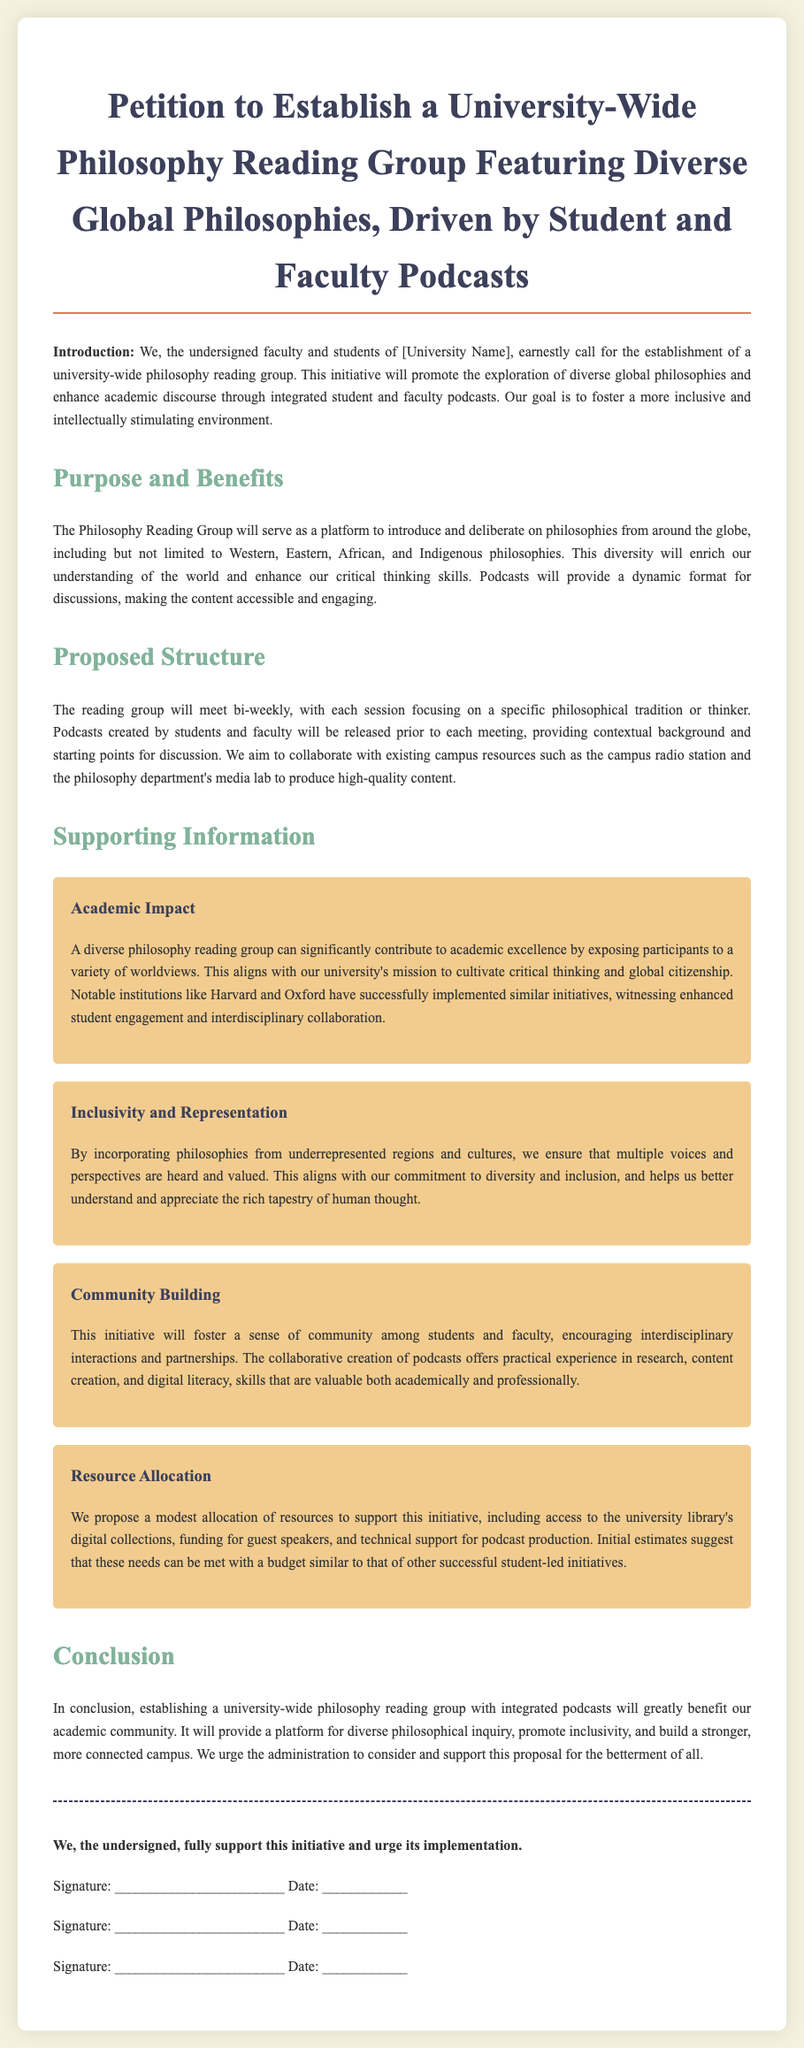What is the title of the petition? The title of the petition is explicitly stated at the beginning of the document.
Answer: Petition to Establish a University-Wide Philosophy Reading Group Featuring Diverse Global Philosophies, Driven by Student and Faculty Podcasts How often will the reading group meet? The document specifies the frequency of the reading group meetings within the proposed structure.
Answer: bi-weekly What will provide context for each discussion session? The document mentions what will be released prior to each meeting to aid discussions.
Answer: Podcasts What is one of the proposals for resource allocation? The section on resource allocation lists specific needs related to the initiative.
Answer: funding for guest speakers Which type of philosophies will be included? The document indicates the scope of philosophies the reading group is expected to explore.
Answer: diverse global philosophies What is the main objective of the reading group? The purpose of the proposed reading group is outlined in the introduction of the document.
Answer: promote the exploration of diverse global philosophies What aligns with the university's mission according to the document? The document highlights how a diverse philosophy reading group contributes to a specific mission.
Answer: cultivate critical thinking and global citizenship Which institutions are mentioned as examples? The supporting information section references notable institutions that have successfully implemented similar initiatives.
Answer: Harvard and Oxford What is the goal for the student and faculty podcasts? The document specifies the intended outcome of using podcasts in the reading group context.
Answer: enhance academic discourse 